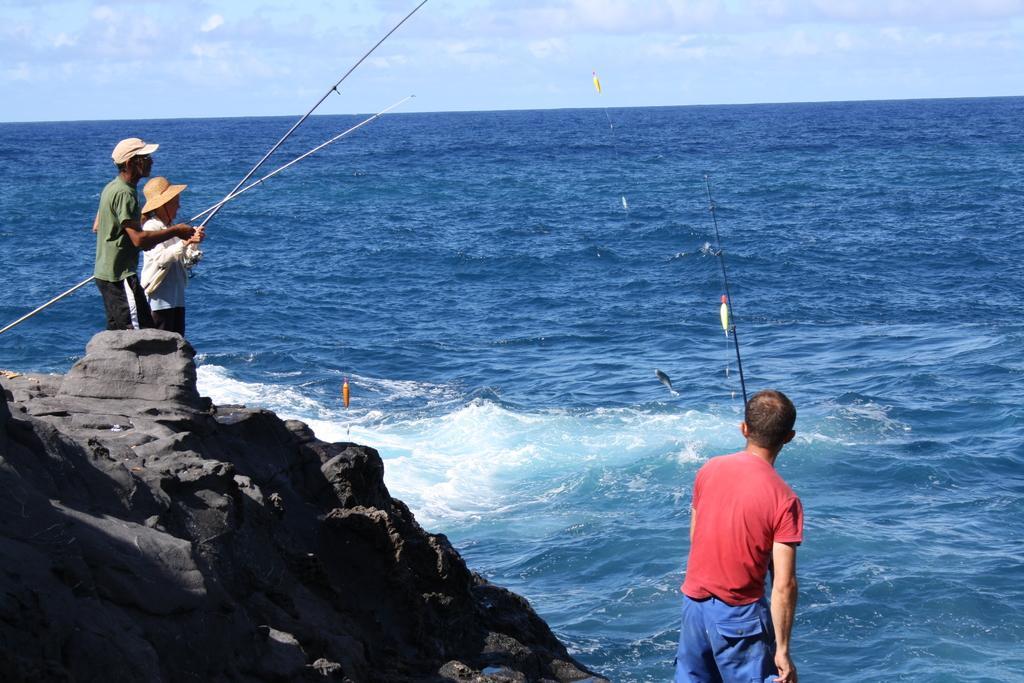Can you describe this image briefly? In the image in the center, we can see three persons are standing and they are holding fishing rods. In the background we can see the sky, clouds and water. 